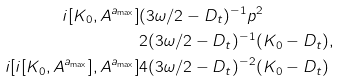Convert formula to latex. <formula><loc_0><loc_0><loc_500><loc_500>i [ K _ { 0 } , A ^ { a _ { \max } } ] & ( 3 \omega / 2 - D _ { t } ) ^ { - 1 } p ^ { 2 } \\ & 2 ( 3 \omega / 2 - D _ { t } ) ^ { - 1 } ( K _ { 0 } - D _ { t } ) , \\ i [ i [ K _ { 0 } , A ^ { a _ { \max } } ] , A ^ { a _ { \max } } ] & 4 ( 3 \omega / 2 - D _ { t } ) ^ { - 2 } ( K _ { 0 } - D _ { t } )</formula> 